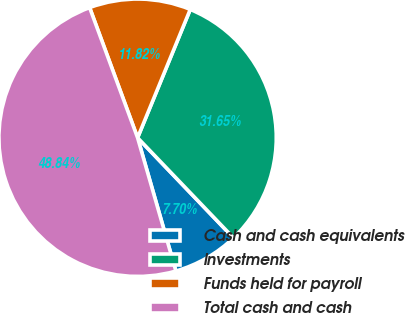Convert chart. <chart><loc_0><loc_0><loc_500><loc_500><pie_chart><fcel>Cash and cash equivalents<fcel>Investments<fcel>Funds held for payroll<fcel>Total cash and cash<nl><fcel>7.7%<fcel>31.65%<fcel>11.82%<fcel>48.84%<nl></chart> 